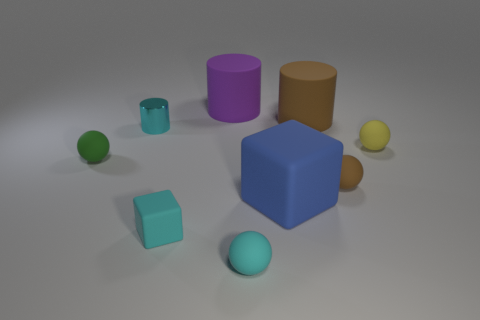The brown object that is the same shape as the big purple object is what size?
Give a very brief answer. Large. How many things are cyan objects left of the cyan matte sphere or spheres in front of the tiny brown rubber object?
Ensure brevity in your answer.  3. There is a cyan matte object that is in front of the matte block left of the blue matte block; what shape is it?
Keep it short and to the point. Sphere. Is there anything else that is the same color as the metallic object?
Provide a short and direct response. Yes. What number of things are either green rubber balls or big shiny objects?
Offer a very short reply. 1. Are there any cyan matte balls that have the same size as the brown sphere?
Provide a short and direct response. Yes. The tiny brown rubber object is what shape?
Provide a succinct answer. Sphere. Are there more cyan cylinders in front of the small cyan rubber sphere than brown cylinders that are left of the brown cylinder?
Your answer should be very brief. No. There is a cylinder that is in front of the big brown cylinder; is it the same color as the rubber block to the left of the small cyan sphere?
Keep it short and to the point. Yes. What is the shape of the brown thing that is the same size as the blue thing?
Your answer should be compact. Cylinder. 